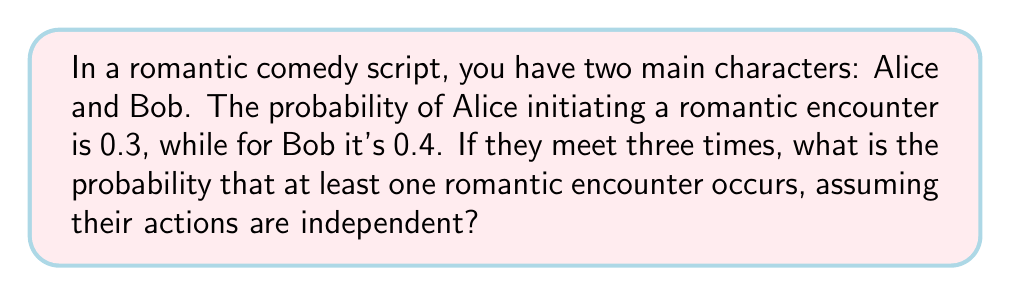Teach me how to tackle this problem. Let's approach this step-by-step:

1) First, let's calculate the probability that no romantic encounter occurs in a single meeting:
   $P(\text{no encounter}) = (1 - 0.3) \times (1 - 0.4) = 0.7 \times 0.6 = 0.42$

2) Now, for three independent meetings, the probability that no romantic encounter occurs in any of them is:
   $P(\text{no encounter in 3 meetings}) = 0.42^3 = 0.07408$

3) Therefore, the probability that at least one romantic encounter occurs is the complement of this:
   $P(\text{at least one encounter}) = 1 - P(\text{no encounter in 3 meetings})$
   $= 1 - 0.07408 = 0.92592$

4) This can be expressed as a percentage:
   $0.92592 \times 100\% = 92.592\%$

This high probability could be used as a plot device in your romantic comedy, perhaps as a humorous contrast to the characters' apparent reluctance or obliviousness to their growing attraction.
Answer: $92.592\%$ 